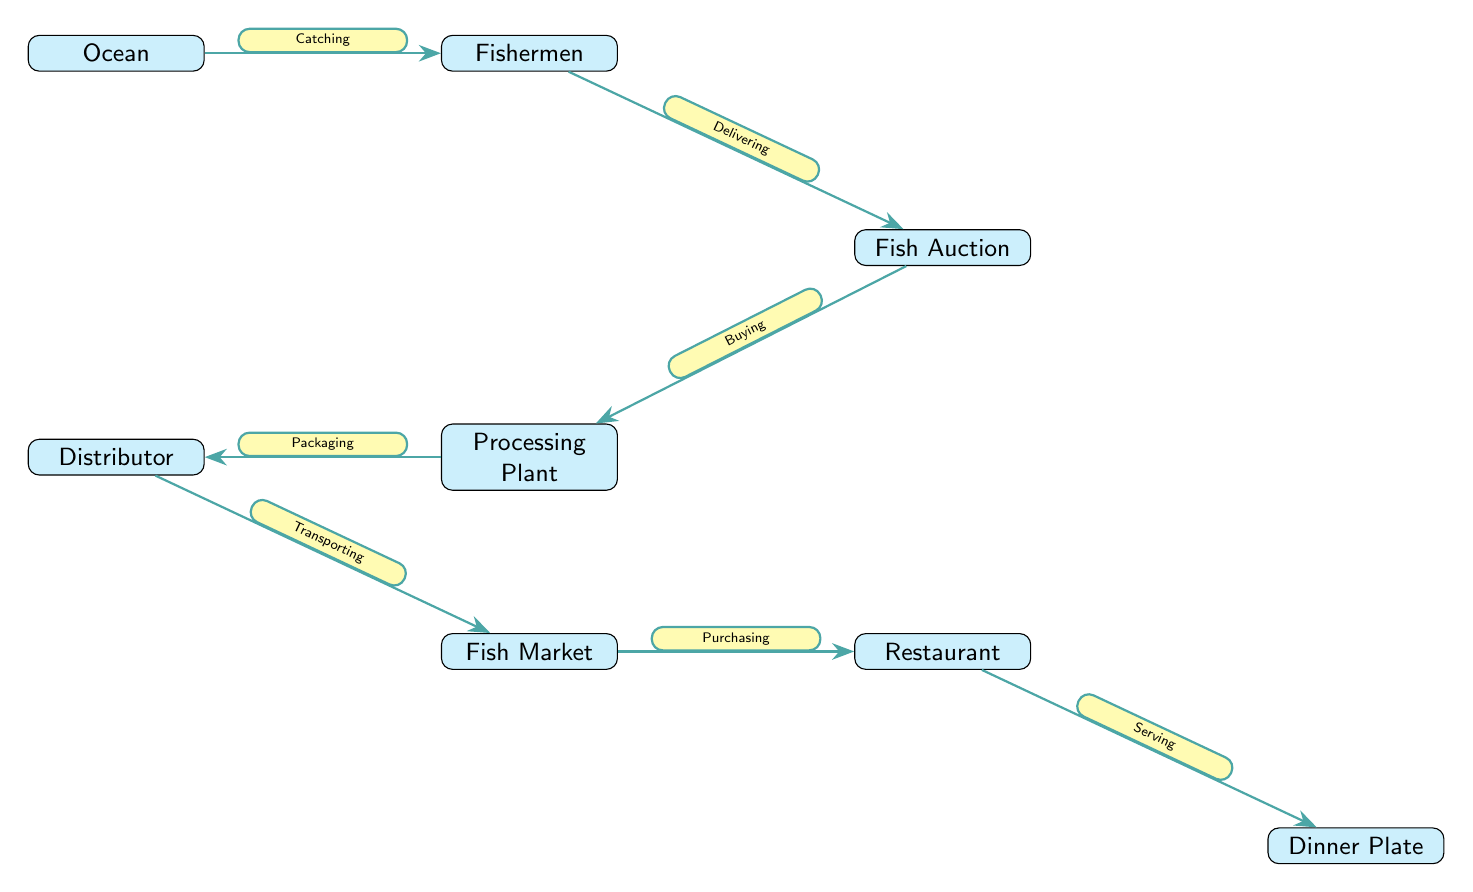What is the first node in the food chain? The first node in the diagram is labeled "Ocean," indicating it is the starting point where seafood is sourced.
Answer: Ocean How many nodes are in the diagram? By counting all distinct points depicted, including the Ocean to the Dinner Plate, there are a total of seven nodes.
Answer: 7 What is the process that follows "Catching"? Directly after "Catching," the next process depicted is "Delivering," showing a flow from the fishermen to the auction.
Answer: Delivering Which node comes after "Processing Plant"? The node that follows "Processing Plant" is labeled "Distributor," indicating what happens next in the seafood journey.
Answer: Distributor What is the last node in the chain? The final node is labeled "Dinner Plate," representing the endpoint of the seafood journey where it is served.
Answer: Dinner Plate How do fish get to the restaurant from the auction? The flow from the auction to the restaurant occurs through several steps: "Buying" leads to "Processing," which then connects to "Distributor" before reaching "Market," and from there, it goes to "Purchasing" at the restaurant.
Answer: Through multiple steps What action occurs between the "Distributor" and "Market"? The action connecting "Distributor" and "Market" is labeled "Transporting," indicating that this is the process that takes place between these two nodes.
Answer: Transporting Which node does "Serving" lead to? The "Serving" action leads directly to the "Dinner Plate," showing that this is where the seafood ends up after being served.
Answer: Dinner Plate What action is taken at the Fish Auction? The action at the Fish Auction is described as "Buying," which represents what stakeholders do at this node.
Answer: Buying 